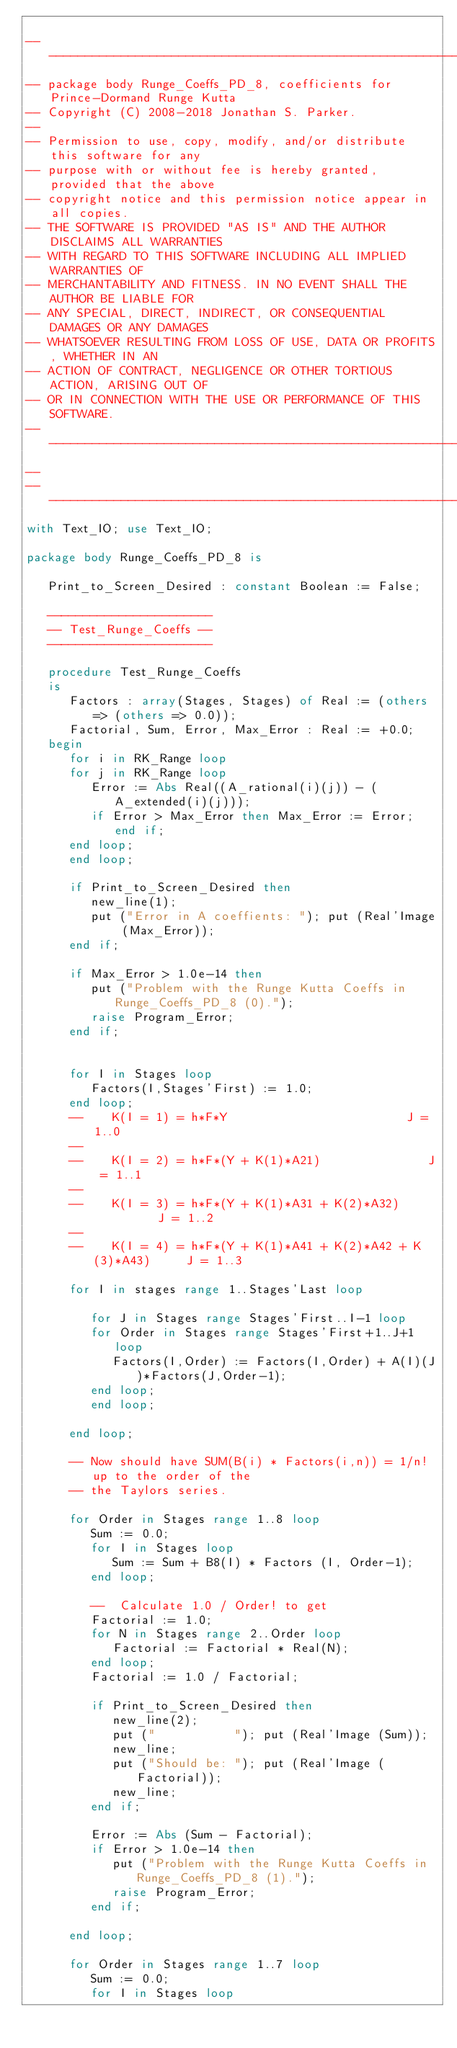<code> <loc_0><loc_0><loc_500><loc_500><_Ada_>
-----------------------------------------------------------------------
-- package body Runge_Coeffs_PD_8, coefficients for Prince-Dormand Runge Kutta
-- Copyright (C) 2008-2018 Jonathan S. Parker.
--
-- Permission to use, copy, modify, and/or distribute this software for any
-- purpose with or without fee is hereby granted, provided that the above
-- copyright notice and this permission notice appear in all copies.
-- THE SOFTWARE IS PROVIDED "AS IS" AND THE AUTHOR DISCLAIMS ALL WARRANTIES
-- WITH REGARD TO THIS SOFTWARE INCLUDING ALL IMPLIED WARRANTIES OF
-- MERCHANTABILITY AND FITNESS. IN NO EVENT SHALL THE AUTHOR BE LIABLE FOR
-- ANY SPECIAL, DIRECT, INDIRECT, OR CONSEQUENTIAL DAMAGES OR ANY DAMAGES
-- WHATSOEVER RESULTING FROM LOSS OF USE, DATA OR PROFITS, WHETHER IN AN
-- ACTION OF CONTRACT, NEGLIGENCE OR OTHER TORTIOUS ACTION, ARISING OUT OF
-- OR IN CONNECTION WITH THE USE OR PERFORMANCE OF THIS SOFTWARE.
-------------------------------------------------------------------------------
--
-----------------------------------------------------------------------
with Text_IO; use Text_IO;

package body Runge_Coeffs_PD_8 is

   Print_to_Screen_Desired : constant Boolean := False;

   -----------------------
   -- Test_Runge_Coeffs --
   -----------------------

   procedure Test_Runge_Coeffs
   is
      Factors : array(Stages, Stages) of Real := (others => (others => 0.0));
      Factorial, Sum, Error, Max_Error : Real := +0.0;
   begin
      for i in RK_Range loop
      for j in RK_Range loop
         Error := Abs Real((A_rational(i)(j)) - (A_extended(i)(j)));
         if Error > Max_Error then Max_Error := Error; end if;
      end loop;
      end loop;

      if Print_to_Screen_Desired then
         new_line(1);
         put ("Error in A coeffients: "); put (Real'Image (Max_Error));
      end if;

      if Max_Error > 1.0e-14 then
         put ("Problem with the Runge Kutta Coeffs in Runge_Coeffs_PD_8 (0).");
         raise Program_Error;
      end if;
      

      for I in Stages loop
         Factors(I,Stages'First) := 1.0;
      end loop;
      --    K(I = 1) = h*F*Y                         J = 1..0
      --
      --    K(I = 2) = h*F*(Y + K(1)*A21)               J = 1..1
      --
      --    K(I = 3) = h*F*(Y + K(1)*A31 + K(2)*A32)          J = 1..2
      --
      --    K(I = 4) = h*F*(Y + K(1)*A41 + K(2)*A42 + K(3)*A43)     J = 1..3

      for I in stages range 1..Stages'Last loop

         for J in Stages range Stages'First..I-1 loop
         for Order in Stages range Stages'First+1..J+1 loop
            Factors(I,Order) := Factors(I,Order) + A(I)(J)*Factors(J,Order-1);
         end loop;
         end loop;

      end loop;

      -- Now should have SUM(B(i) * Factors(i,n)) = 1/n! up to the order of the
      -- the Taylors series.

      for Order in Stages range 1..8 loop
         Sum := 0.0;
         for I in Stages loop
            Sum := Sum + B8(I) * Factors (I, Order-1);
         end loop;

         --  Calculate 1.0 / Order! to get
         Factorial := 1.0;
         for N in Stages range 2..Order loop
            Factorial := Factorial * Real(N);
         end loop;
         Factorial := 1.0 / Factorial;

         if Print_to_Screen_Desired then
            new_line(2);
            put ("           "); put (Real'Image (Sum));
            new_line;
            put ("Should be: "); put (Real'Image (Factorial));
            new_line;
         end if;

         Error := Abs (Sum - Factorial);
         if Error > 1.0e-14 then
            put ("Problem with the Runge Kutta Coeffs in Runge_Coeffs_PD_8 (1).");
            raise Program_Error;
         end if;
      
      end loop;

      for Order in Stages range 1..7 loop
         Sum := 0.0;
         for I in Stages loop</code> 